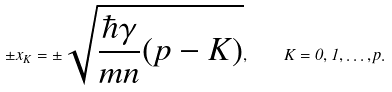Convert formula to latex. <formula><loc_0><loc_0><loc_500><loc_500>\pm x _ { K } = \pm \sqrt { \frac { \hbar { \gamma } } { m n } ( p - K ) } , \quad K = 0 , 1 , \dots , p .</formula> 